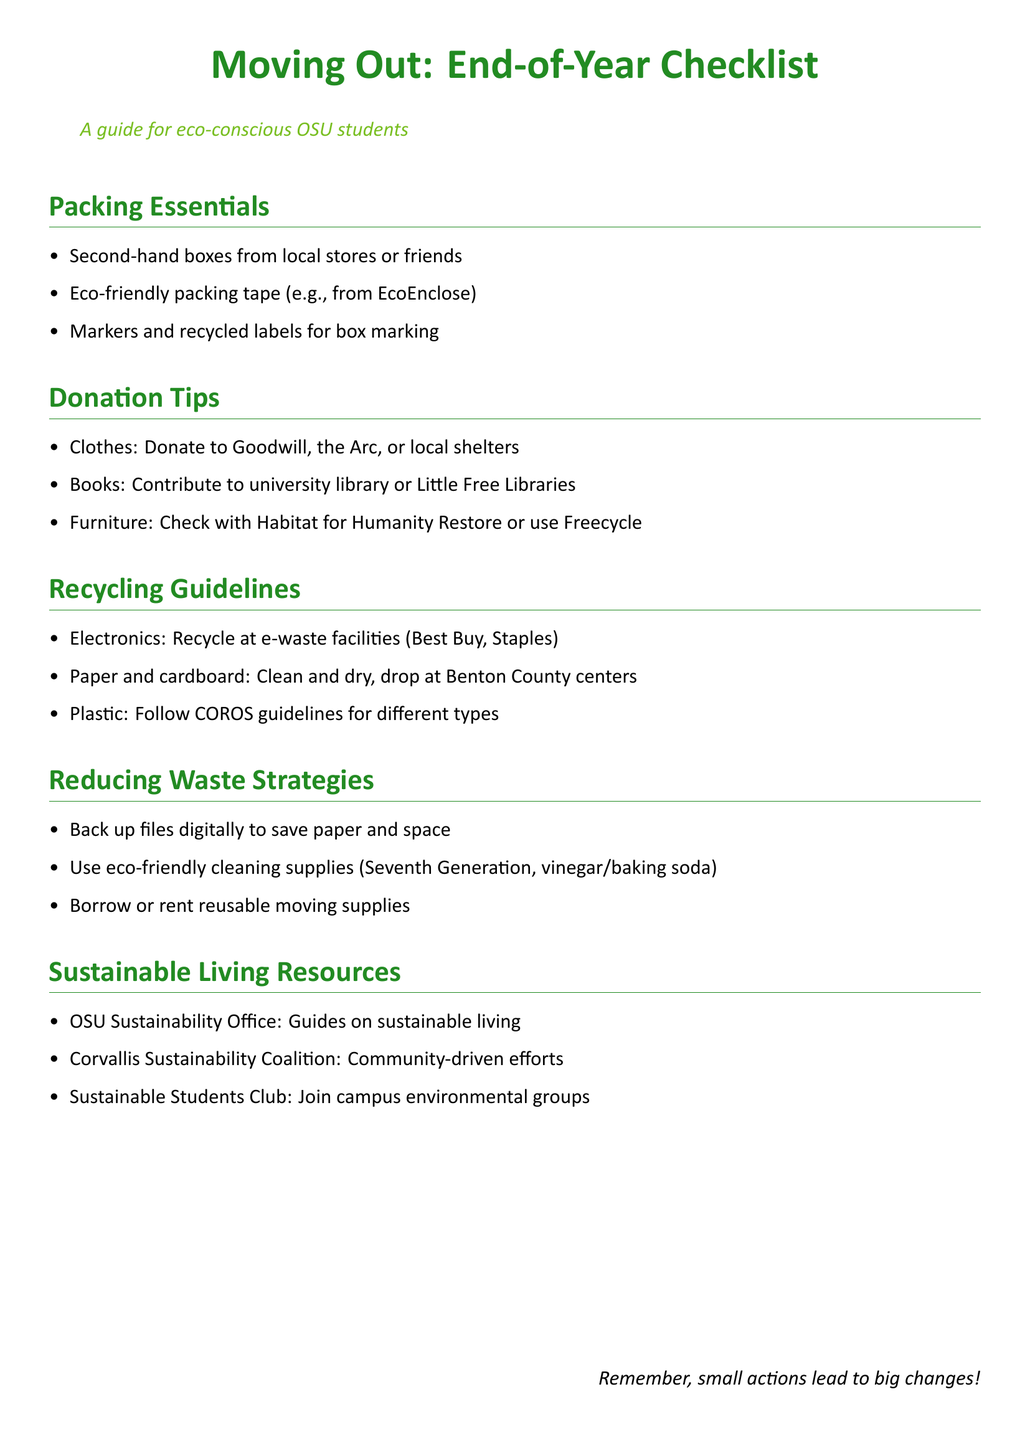What should you use for packing tape? The document suggests using eco-friendly packing tape from EcoEnclose.
Answer: Eco-friendly packing tape Where can you donate clothes? Clothes can be donated to Goodwill, the Arc, or local shelters as per the donation tips.
Answer: Goodwill, the Arc, local shelters What type of facility should electronics be recycled at? The document states that electronics should be recycled at e-waste facilities like Best Buy and Staples.
Answer: e-waste facilities What is one strategy to reduce waste during moving? One strategy mentioned is to back up files digitally to save paper and space.
Answer: Back up files digitally Which organization provides guides on sustainable living? The OSU Sustainability Office provides resources on sustainable living.
Answer: OSU Sustainability Office How are paper and cardboard supposed to be before recycling? The document specifies that paper and cardboard should be clean and dry before being recycled.
Answer: Clean and dry What should you do with furniture you don’t need? You should check with Habitat for Humanity Restore or use Freecycle for furniture you no longer need.
Answer: Habitat for Humanity Restore, Freecycle What is the focus of the Sustainable Students Club? The Sustainable Students Club focuses on joining campus environmental groups.
Answer: Campus environmental groups How is the checklist document categorized? The checklist is categorized as a guide for eco-conscious OSU students.
Answer: Eco-conscious OSU students 